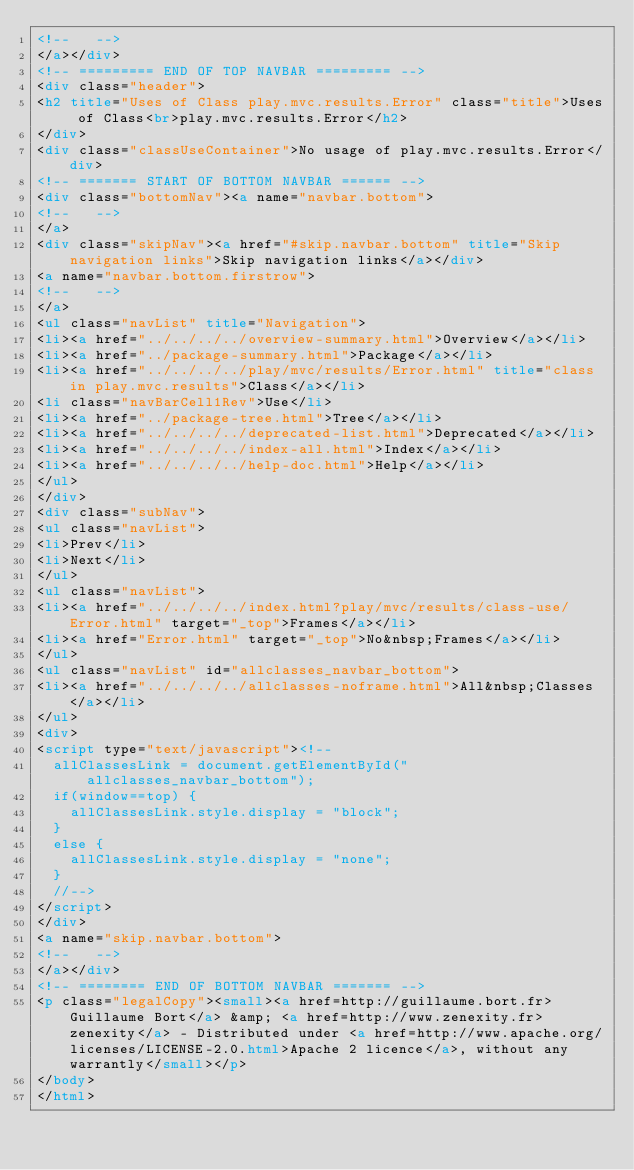<code> <loc_0><loc_0><loc_500><loc_500><_HTML_><!--   -->
</a></div>
<!-- ========= END OF TOP NAVBAR ========= -->
<div class="header">
<h2 title="Uses of Class play.mvc.results.Error" class="title">Uses of Class<br>play.mvc.results.Error</h2>
</div>
<div class="classUseContainer">No usage of play.mvc.results.Error</div>
<!-- ======= START OF BOTTOM NAVBAR ====== -->
<div class="bottomNav"><a name="navbar.bottom">
<!--   -->
</a>
<div class="skipNav"><a href="#skip.navbar.bottom" title="Skip navigation links">Skip navigation links</a></div>
<a name="navbar.bottom.firstrow">
<!--   -->
</a>
<ul class="navList" title="Navigation">
<li><a href="../../../../overview-summary.html">Overview</a></li>
<li><a href="../package-summary.html">Package</a></li>
<li><a href="../../../../play/mvc/results/Error.html" title="class in play.mvc.results">Class</a></li>
<li class="navBarCell1Rev">Use</li>
<li><a href="../package-tree.html">Tree</a></li>
<li><a href="../../../../deprecated-list.html">Deprecated</a></li>
<li><a href="../../../../index-all.html">Index</a></li>
<li><a href="../../../../help-doc.html">Help</a></li>
</ul>
</div>
<div class="subNav">
<ul class="navList">
<li>Prev</li>
<li>Next</li>
</ul>
<ul class="navList">
<li><a href="../../../../index.html?play/mvc/results/class-use/Error.html" target="_top">Frames</a></li>
<li><a href="Error.html" target="_top">No&nbsp;Frames</a></li>
</ul>
<ul class="navList" id="allclasses_navbar_bottom">
<li><a href="../../../../allclasses-noframe.html">All&nbsp;Classes</a></li>
</ul>
<div>
<script type="text/javascript"><!--
  allClassesLink = document.getElementById("allclasses_navbar_bottom");
  if(window==top) {
    allClassesLink.style.display = "block";
  }
  else {
    allClassesLink.style.display = "none";
  }
  //-->
</script>
</div>
<a name="skip.navbar.bottom">
<!--   -->
</a></div>
<!-- ======== END OF BOTTOM NAVBAR ======= -->
<p class="legalCopy"><small><a href=http://guillaume.bort.fr>Guillaume Bort</a> &amp; <a href=http://www.zenexity.fr>zenexity</a> - Distributed under <a href=http://www.apache.org/licenses/LICENSE-2.0.html>Apache 2 licence</a>, without any warrantly</small></p>
</body>
</html>
</code> 